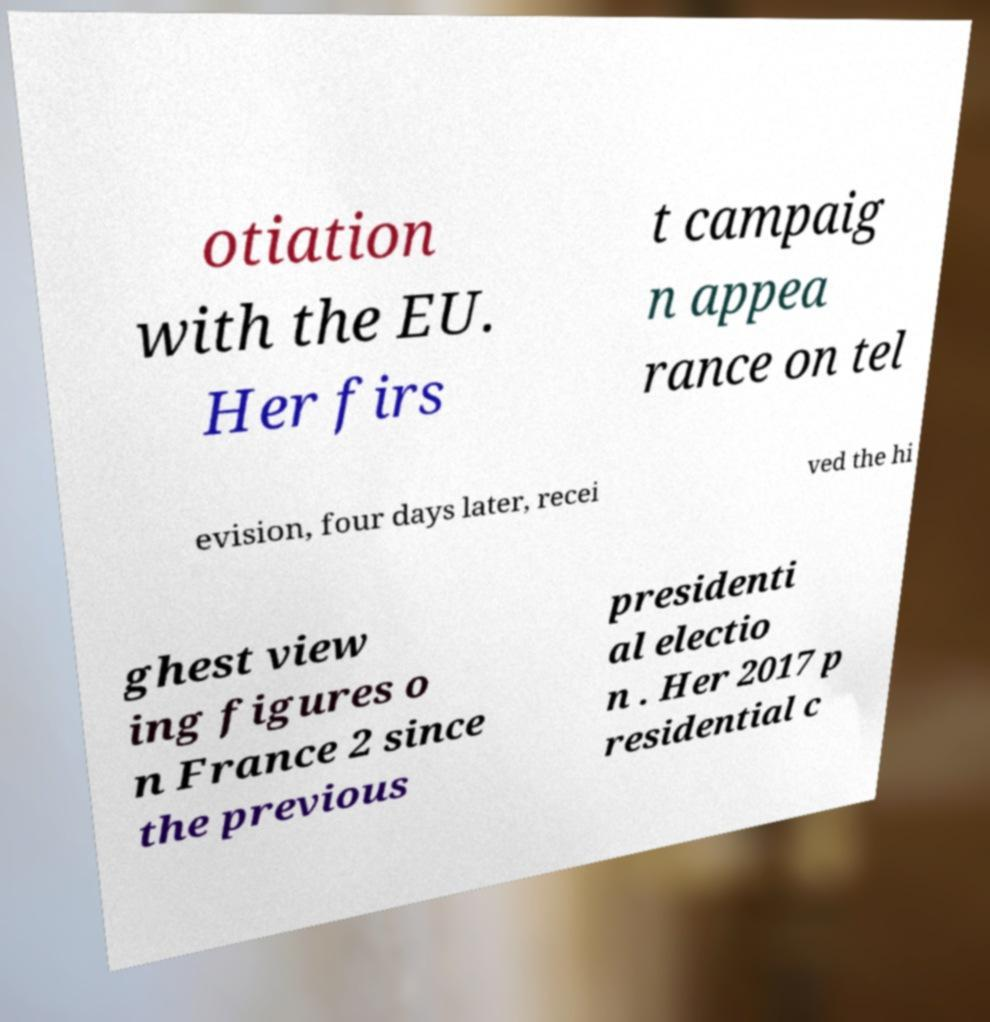For documentation purposes, I need the text within this image transcribed. Could you provide that? otiation with the EU. Her firs t campaig n appea rance on tel evision, four days later, recei ved the hi ghest view ing figures o n France 2 since the previous presidenti al electio n . Her 2017 p residential c 